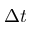<formula> <loc_0><loc_0><loc_500><loc_500>\Delta t</formula> 